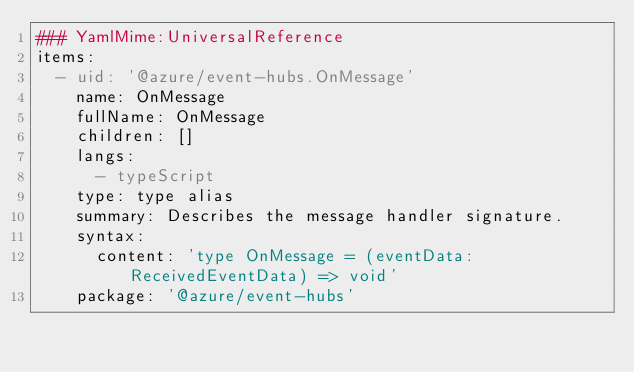Convert code to text. <code><loc_0><loc_0><loc_500><loc_500><_YAML_>### YamlMime:UniversalReference
items:
  - uid: '@azure/event-hubs.OnMessage'
    name: OnMessage
    fullName: OnMessage
    children: []
    langs:
      - typeScript
    type: type alias
    summary: Describes the message handler signature.
    syntax:
      content: 'type OnMessage = (eventData: ReceivedEventData) => void'
    package: '@azure/event-hubs'
</code> 